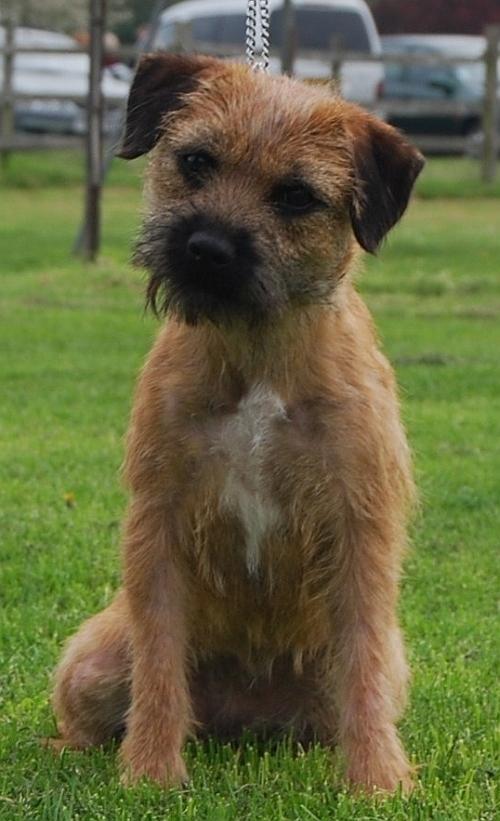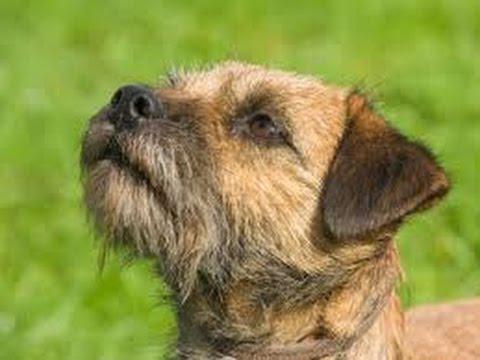The first image is the image on the left, the second image is the image on the right. Analyze the images presented: Is the assertion "Both dogs are standing in profile and facing the same direction." valid? Answer yes or no. No. The first image is the image on the left, the second image is the image on the right. For the images shown, is this caption "The dogs in the right and left images have the same pose and face the same direction." true? Answer yes or no. No. 